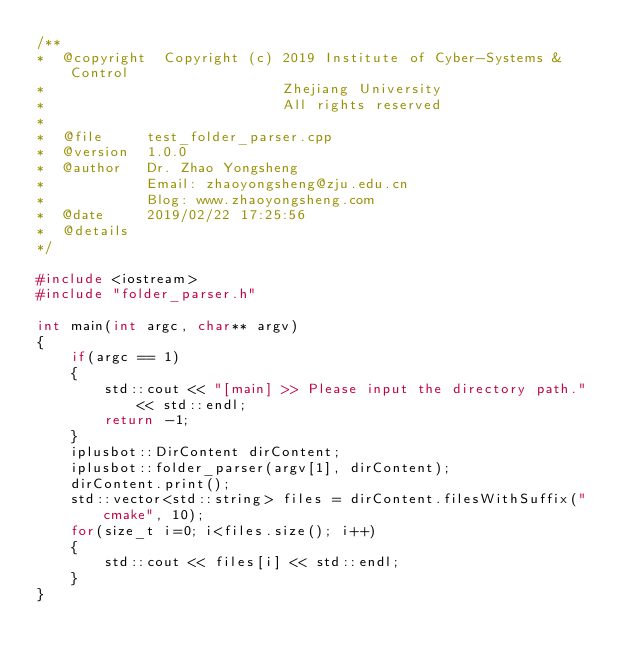Convert code to text. <code><loc_0><loc_0><loc_500><loc_500><_C++_>/**
*  @copyright  Copyright (c) 2019 Institute of Cyber-Systems & Control
*                            Zhejiang University
*                            All rights reserved
*
*  @file     test_folder_parser.cpp
*  @version  1.0.0
*  @author   Dr. Zhao Yongsheng
*            Email: zhaoyongsheng@zju.edu.cn
*            Blog: www.zhaoyongsheng.com
*  @date     2019/02/22 17:25:56
*  @details       
*/

#include <iostream>
#include "folder_parser.h"

int main(int argc, char** argv)
{
    if(argc == 1)
    {
        std::cout << "[main] >> Please input the directory path." << std::endl;
        return -1;
    }
    iplusbot::DirContent dirContent;
    iplusbot::folder_parser(argv[1], dirContent);
    dirContent.print();
    std::vector<std::string> files = dirContent.filesWithSuffix("cmake", 10);
    for(size_t i=0; i<files.size(); i++)
    {
        std::cout << files[i] << std::endl;
    }
}</code> 